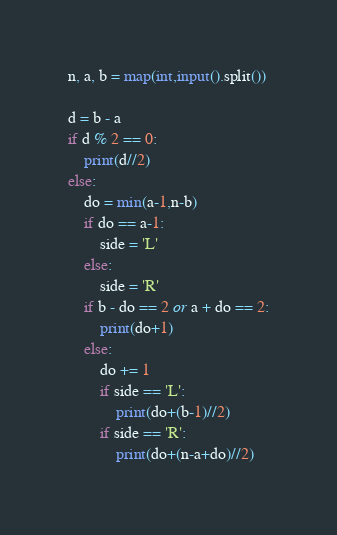Convert code to text. <code><loc_0><loc_0><loc_500><loc_500><_Python_>n, a, b = map(int,input().split())

d = b - a
if d % 2 == 0:
    print(d//2)
else:
    do = min(a-1,n-b)
    if do == a-1:
        side = 'L'
    else:
        side = 'R'
    if b - do == 2 or a + do == 2:
        print(do+1)
    else:
        do += 1
        if side == 'L':
            print(do+(b-1)//2)
        if side == 'R':
            print(do+(n-a+do)//2)</code> 